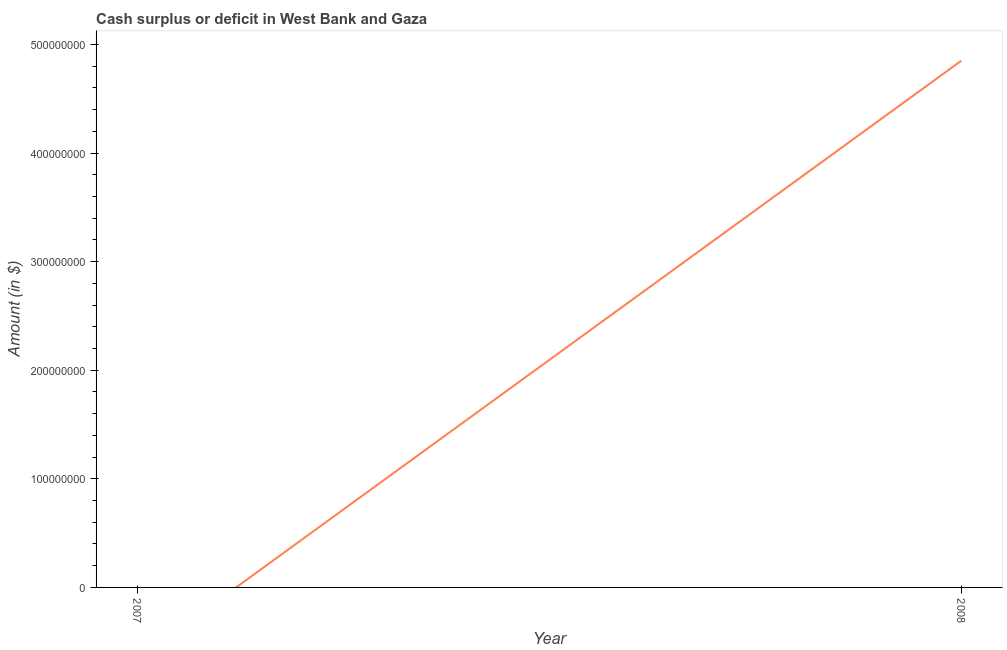What is the cash surplus or deficit in 2007?
Provide a succinct answer. 0. Across all years, what is the maximum cash surplus or deficit?
Your answer should be very brief. 4.85e+08. Across all years, what is the minimum cash surplus or deficit?
Offer a very short reply. 0. In which year was the cash surplus or deficit maximum?
Offer a very short reply. 2008. What is the sum of the cash surplus or deficit?
Provide a succinct answer. 4.85e+08. What is the average cash surplus or deficit per year?
Make the answer very short. 2.42e+08. What is the median cash surplus or deficit?
Offer a very short reply. 2.42e+08. In how many years, is the cash surplus or deficit greater than the average cash surplus or deficit taken over all years?
Offer a terse response. 1. Does the graph contain grids?
Your answer should be compact. No. What is the title of the graph?
Your answer should be compact. Cash surplus or deficit in West Bank and Gaza. What is the label or title of the Y-axis?
Keep it short and to the point. Amount (in $). What is the Amount (in $) in 2008?
Your answer should be very brief. 4.85e+08. 